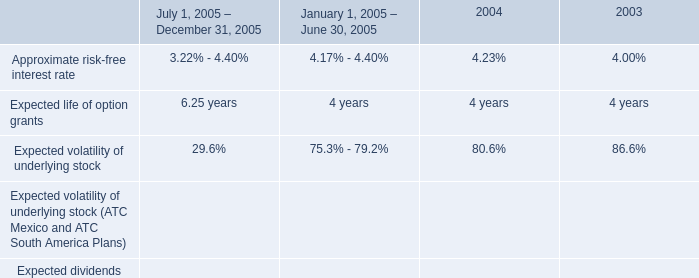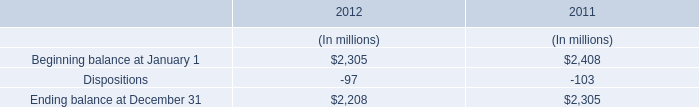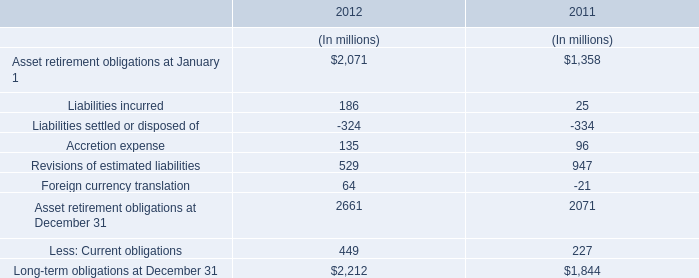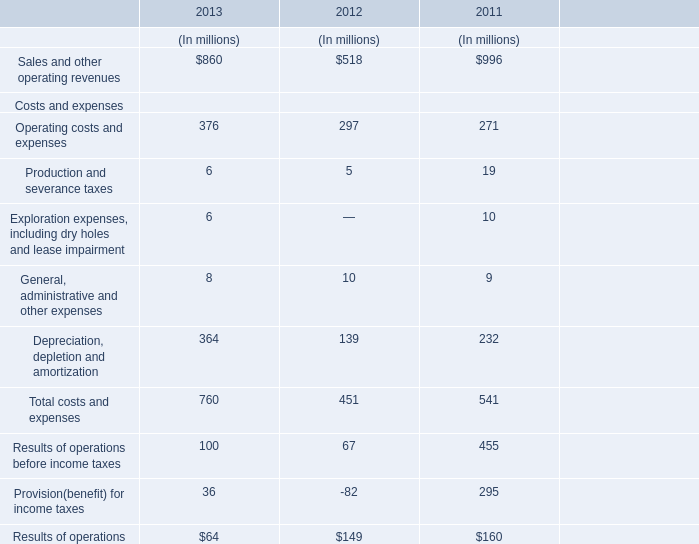How many years are the Total costs and expenses less than 700 million? 
Answer: 2. 